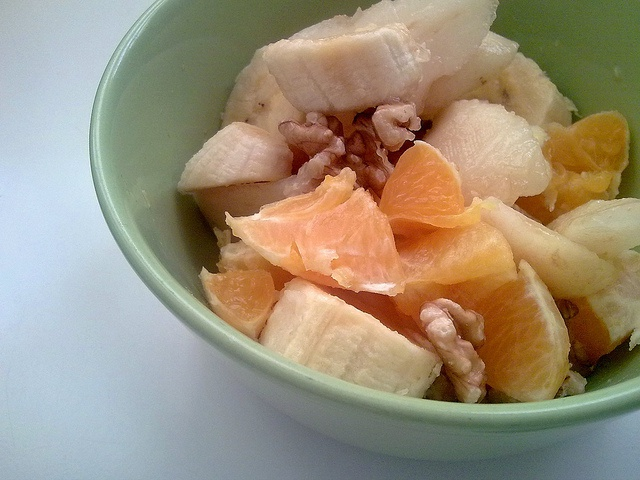Describe the objects in this image and their specific colors. I can see bowl in darkgray, gray, tan, and olive tones, orange in darkgray, tan, and red tones, banana in darkgray, gray, and tan tones, banana in darkgray and tan tones, and orange in darkgray, olive, tan, and maroon tones in this image. 